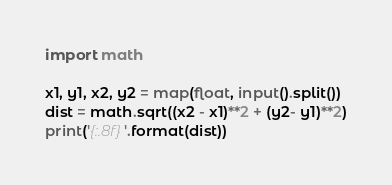Convert code to text. <code><loc_0><loc_0><loc_500><loc_500><_Python_>import math

x1, y1, x2, y2 = map(float, input().split())
dist = math.sqrt((x2 - x1)**2 + (y2- y1)**2)
print('{:.8f}'.format(dist))
</code> 